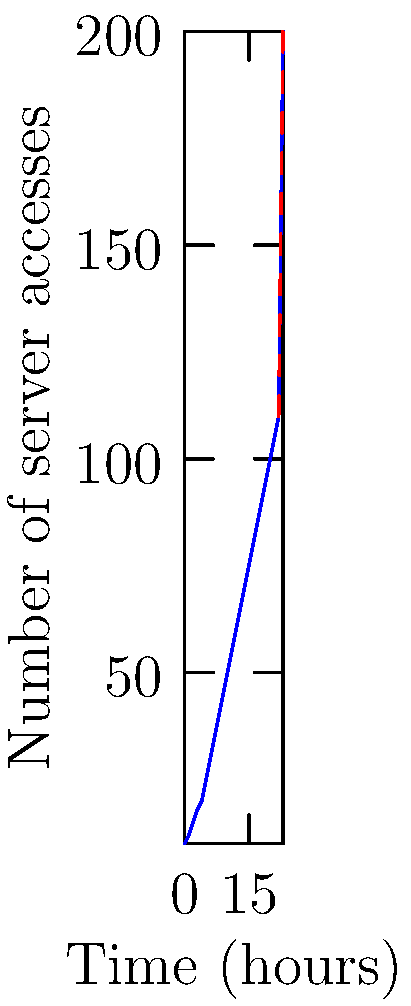Based on the time series graph showing server access patterns over a 24-hour period, at which hour does an anomaly in the access pattern become apparent, potentially indicating a security threat to your serverless application? To identify the anomaly in the server access pattern, we need to analyze the graph step-by-step:

1. The graph shows the number of server accesses over a 24-hour period (x-axis) against the number of accesses (y-axis).

2. From hours 0 to 22, we observe a gradual increase in server accesses, which appears to follow a typical daily pattern for a growing application.

3. The line is relatively smooth and continuous up to hour 22, indicating a consistent trend.

4. However, between hours 22 and 23, there is a sudden and dramatic spike in the number of server accesses.

5. This spike is represented by a red dashed line, which is visually distinct from the rest of the blue line graph.

6. The number of accesses jumps from around 110 at hour 22 to 200 at hour 23, which is a much steeper increase compared to the previous hours.

7. This abrupt change in the access pattern at hour 23 is inconsistent with the established trend and represents an anomaly.

8. For a startup founder concerned about security, this sudden spike could indicate a potential security threat, such as a DDoS attack or unauthorized access attempts.

Therefore, the anomaly in the access pattern becomes apparent at hour 23, which is the point where the graph shows a significant and unexpected increase in server accesses.
Answer: Hour 23 